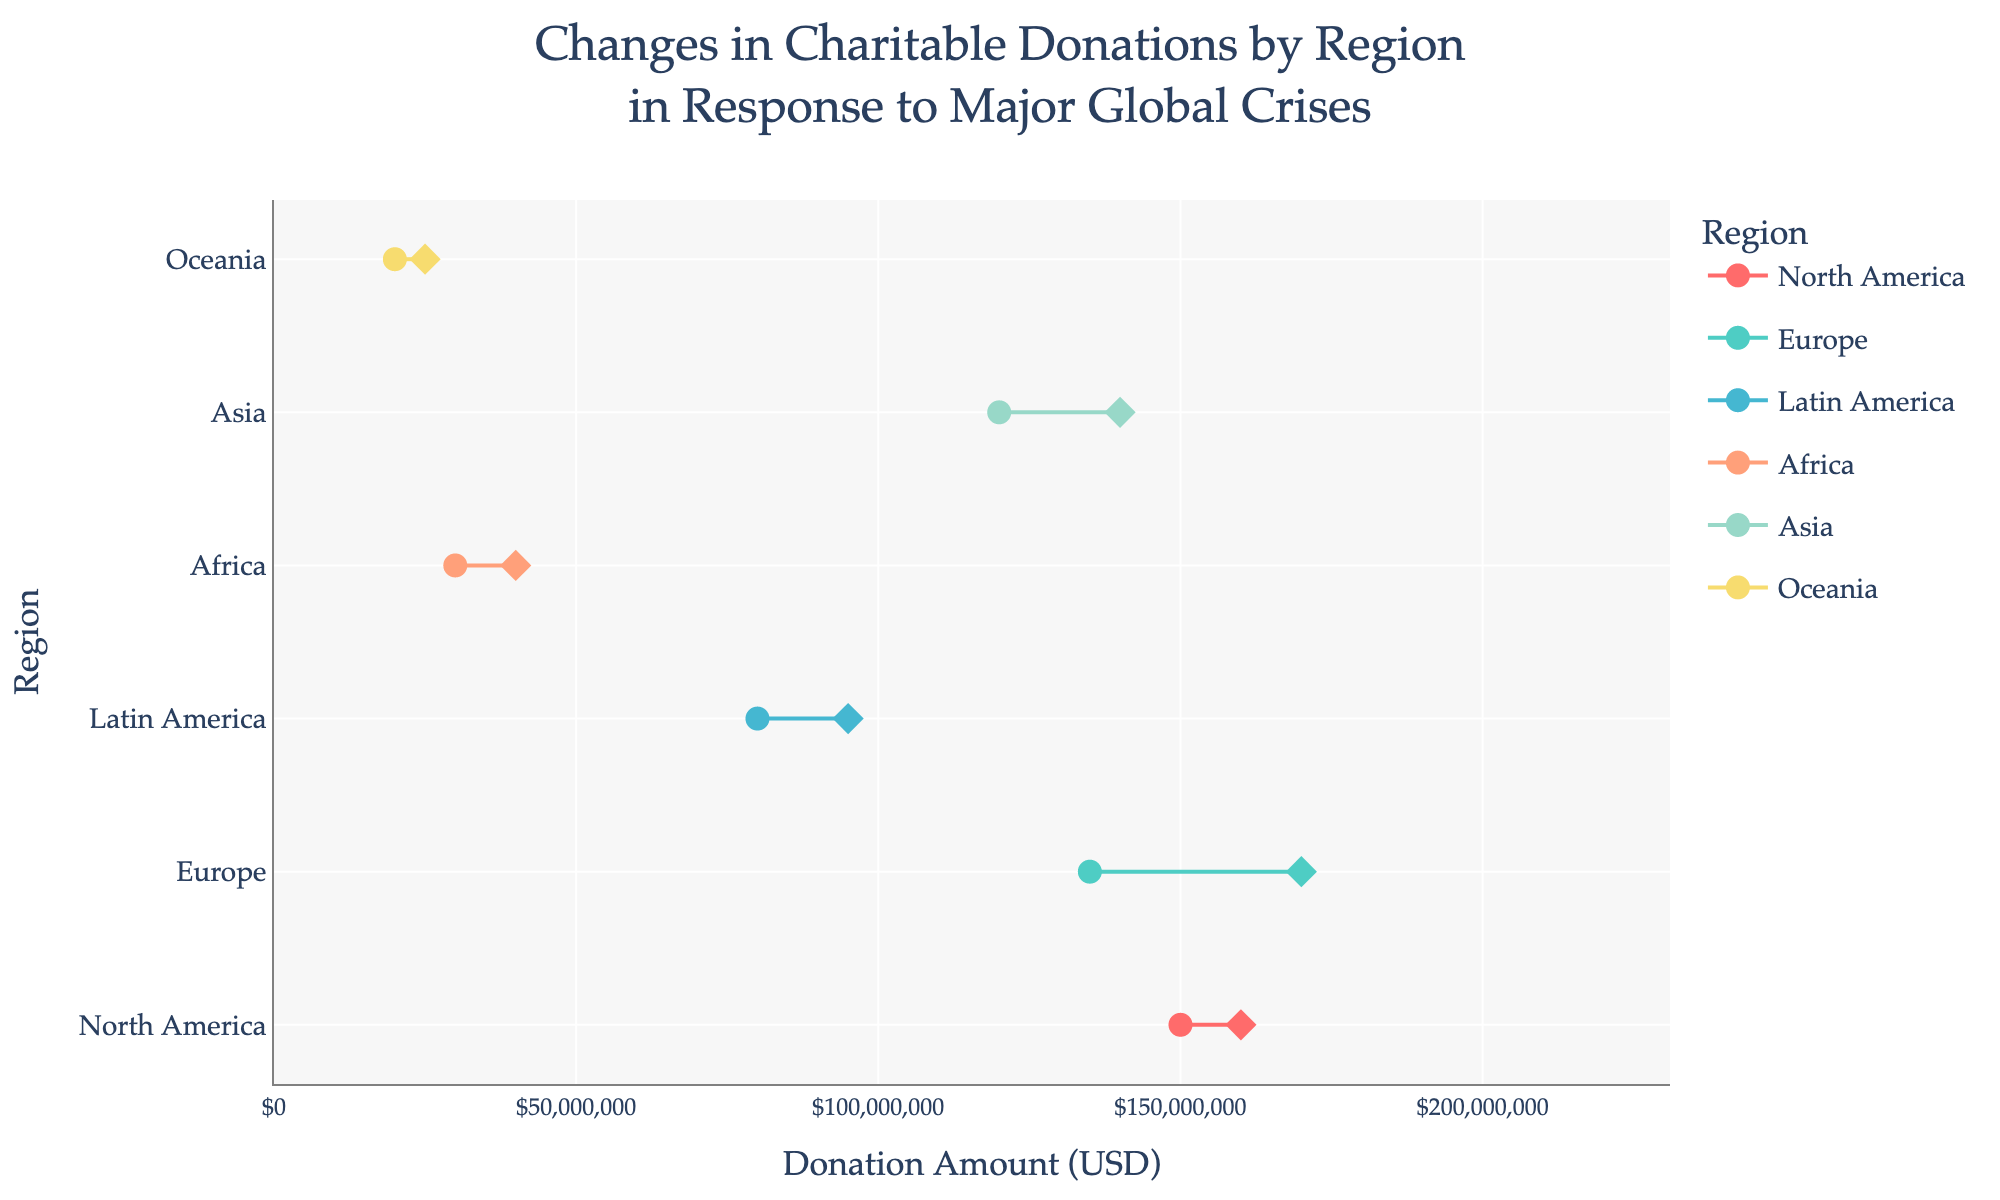what is the title of the plot? The title is displayed at the top of the plot. It reads "Changes in Charitable Donations by Region in Response to Major Global Crises".
Answer: Changes in Charitable Donations by Region in Response to Major Global Crises Which region has the highest post-crisis donation amount in 2022? By analyzing the plot, Europe shows the highest post-crisis donation amount with $210,000,000.
Answer: Europe How much did donations increase for North America due to the COVID-19 pandemic? For North America, the pre-crisis donation was $150,000,000, and the post-crisis donation was $160,000,000. The increase is calculated as $160,000,000 - $150,000,000 = $10,000,000.
Answer: $10,000,000 Compare the donation increase in Latin America during the Amazon Rainforest Fires to the COVID-19 Pandemic. Which was higher? The increase during the Amazon Rainforest Fires was $95,000,000 - $80,000,000 = $15,000,000. The increase during the COVID-19 Pandemic was $105,000,000 - $90,000,000 = $15,000,000. Both crises had the same increase of $15,000,000.
Answer: Equal What is the color of the dumbbell lines used for Africa? The line and markers for Africa are colored with a distinct shade that is consistent for Africa across the entire plot. This color corresponds to the fourth position in the color scheme, which is '#FFA07A'.
Answer: '#FFA07A' Which region saw the largest increase in donations from pre- to post-crisis amounts for the Ukrainian Refugee Crisis? For the Ukrainian Refugee Crisis in 2022, North America’s increase was $190,000,000 - $175,000,000 = $15,000,000 and Europe’s increase was $210,000,000 - $160,000,000 = $50,000,000. Hence, Europe saw the largest increase.
Answer: Europe If we sum all the post-crisis donations for the COVID-19 pandemic across all regions shown, what is the total amount? Adding post-crisis donations for COVID-19: North America ($160,000,000), Europe ($170,000,000), Latin America ($105,000,000), Asia ($150,000,000), and Oceania ($280,000,000). The sum is $160,000,000 + $170,000,000 + $105,000,000 + $150,000,000 + $280,000,000 = $865,000,000.
Answer: $865,000,000 